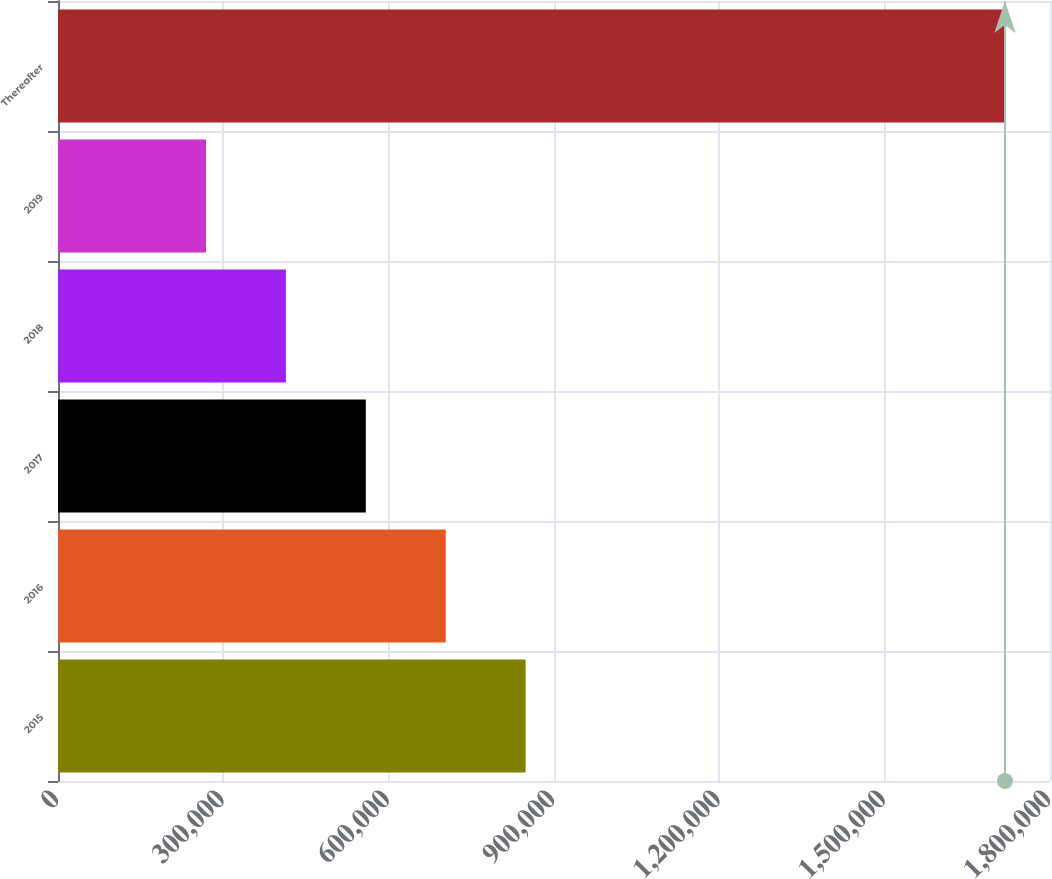Convert chart. <chart><loc_0><loc_0><loc_500><loc_500><bar_chart><fcel>2015<fcel>2016<fcel>2017<fcel>2018<fcel>2019<fcel>Thereafter<nl><fcel>848462<fcel>703496<fcel>558531<fcel>413565<fcel>268600<fcel>1.71825e+06<nl></chart> 